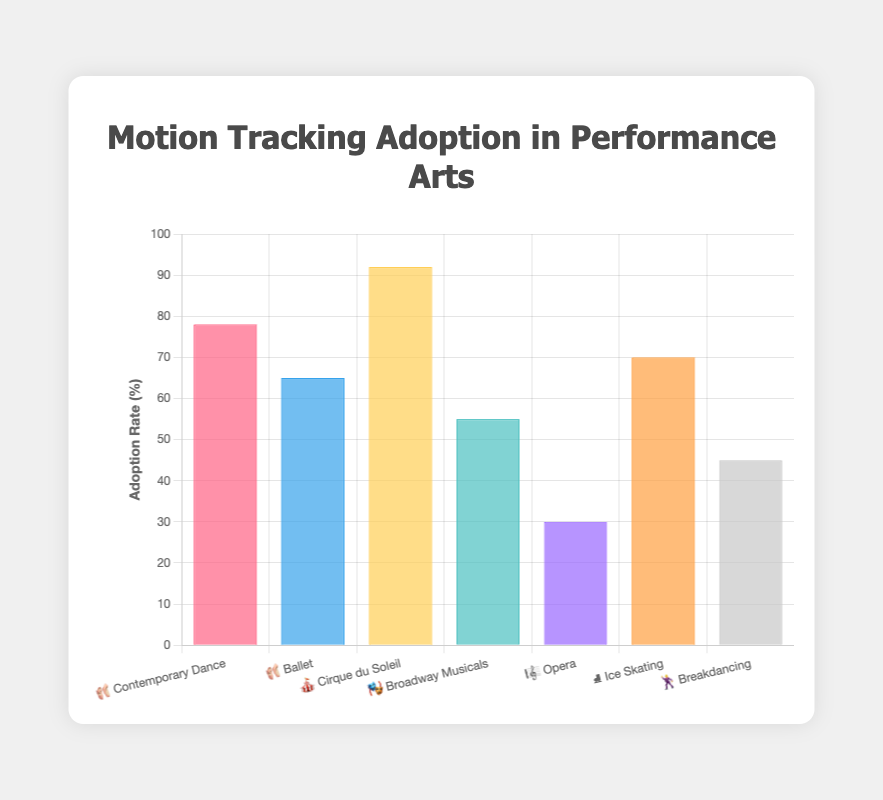How many performance arts have an adoption rate of motion tracking technology above 50%? To find the answer, list all performance arts with their adoption rates and count the ones above 50%. The performance arts with adoption rates above 50% are Contemporary Dance (78%), Ballet (65%), Cirque du Soleil (92%), Broadway Musicals (55%), and Ice Skating (70%). Hence, there are 5 performance arts.
Answer: 5 Which performance art has the highest adoption rate of motion tracking technology? Review the adoption rates for each performance art and identify the one with the highest percentage. Cirque du Soleil stands out with an adoption rate of 92%.
Answer: Cirque du Soleil What is the difference in adoption rates between Contemporary Dance and Ice Skating? Subtract the adoption rate of Ice Skating from that of Contemporary Dance. Contemporary Dance has an adoption rate of 78% while Ice Skating has 70%. So, the difference is 78% - 70% = 8%.
Answer: 8% Which performance art has the lowest adoption rate of motion tracking technology? Compare all adoption rates and find the lowest one. Opera has the lowest adoption rate at 30%.
Answer: Opera How many performance arts have an adoption rate below 50%? List all the performance arts with their adoption rates and count those with rates below 50%. The arts with rates below 50% are Opera (30%) and Breakdancing (45%). Therefore, there are 2 performance arts.
Answer: 2 Between Ballet and Broadway Musicals, which has a higher adoption rate of motion tracking technology? Compare the adoption rates of Ballet and Broadway Musicals. Ballet has an adoption rate of 65% and Broadway Musicals has 55%. Thus, Ballet has a higher adoption rate.
Answer: Ballet What is the median adoption rate of motion tracking technology across the listed performance arts? List the adoption rates in ascending order (30, 45, 55, 65, 70, 78, 92) and find the median value, which is the middle number in an odd set of numbers. The median adoption rate is 65%.
Answer: 65% What is the average adoption rate of motion tracking technology in the data provided? Calculate the sum of all adoption rates (78 + 65 + 92 + 55 + 30 + 70 + 45 = 435) and divide by the number of performance arts (7). The average adoption rate is 435 / 7 ≈ 62.14%.
Answer: ~62.14% By how much does Cirque du Soleil's adoption rate surpass the average adoption rate of motion tracking technology? First, compute the average adoption rate (62.14%). Then, subtract this average from Cirque du Soleil's rate (92%). The difference is 92% - 62.14% ≈ 29.86%.
Answer: ~29.86% What is the total combined adoption rate percentage of Ballet, Ice Skating, and Breakdancing? Sum the adoption rates of Ballet (65%), Ice Skating (70%), and Breakdancing (45%). The total combined adoption rate is 65% + 70% + 45% = 180%.
Answer: 180% 